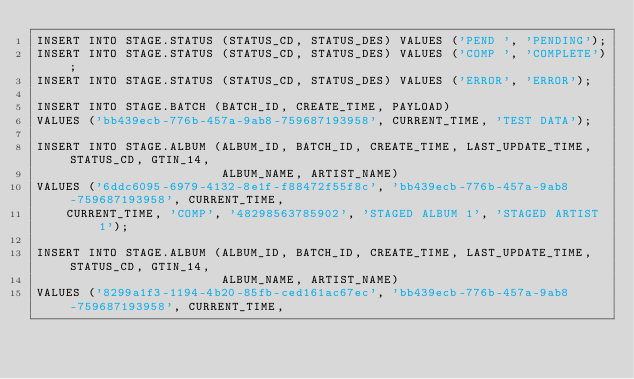Convert code to text. <code><loc_0><loc_0><loc_500><loc_500><_SQL_>INSERT INTO STAGE.STATUS (STATUS_CD, STATUS_DES) VALUES ('PEND ', 'PENDING');
INSERT INTO STAGE.STATUS (STATUS_CD, STATUS_DES) VALUES ('COMP ', 'COMPLETE');
INSERT INTO STAGE.STATUS (STATUS_CD, STATUS_DES) VALUES ('ERROR', 'ERROR');

INSERT INTO STAGE.BATCH (BATCH_ID, CREATE_TIME, PAYLOAD)
VALUES ('bb439ecb-776b-457a-9ab8-759687193958', CURRENT_TIME, 'TEST DATA');

INSERT INTO STAGE.ALBUM (ALBUM_ID, BATCH_ID, CREATE_TIME, LAST_UPDATE_TIME, STATUS_CD, GTIN_14,
                         ALBUM_NAME, ARTIST_NAME)
VALUES ('6ddc6095-6979-4132-8e1f-f88472f55f8c', 'bb439ecb-776b-457a-9ab8-759687193958', CURRENT_TIME,
    CURRENT_TIME, 'COMP', '48298563785902', 'STAGED ALBUM 1', 'STAGED ARTIST 1');

INSERT INTO STAGE.ALBUM (ALBUM_ID, BATCH_ID, CREATE_TIME, LAST_UPDATE_TIME, STATUS_CD, GTIN_14,
                         ALBUM_NAME, ARTIST_NAME)
VALUES ('8299a1f3-1194-4b20-85fb-ced161ac67ec', 'bb439ecb-776b-457a-9ab8-759687193958', CURRENT_TIME,</code> 